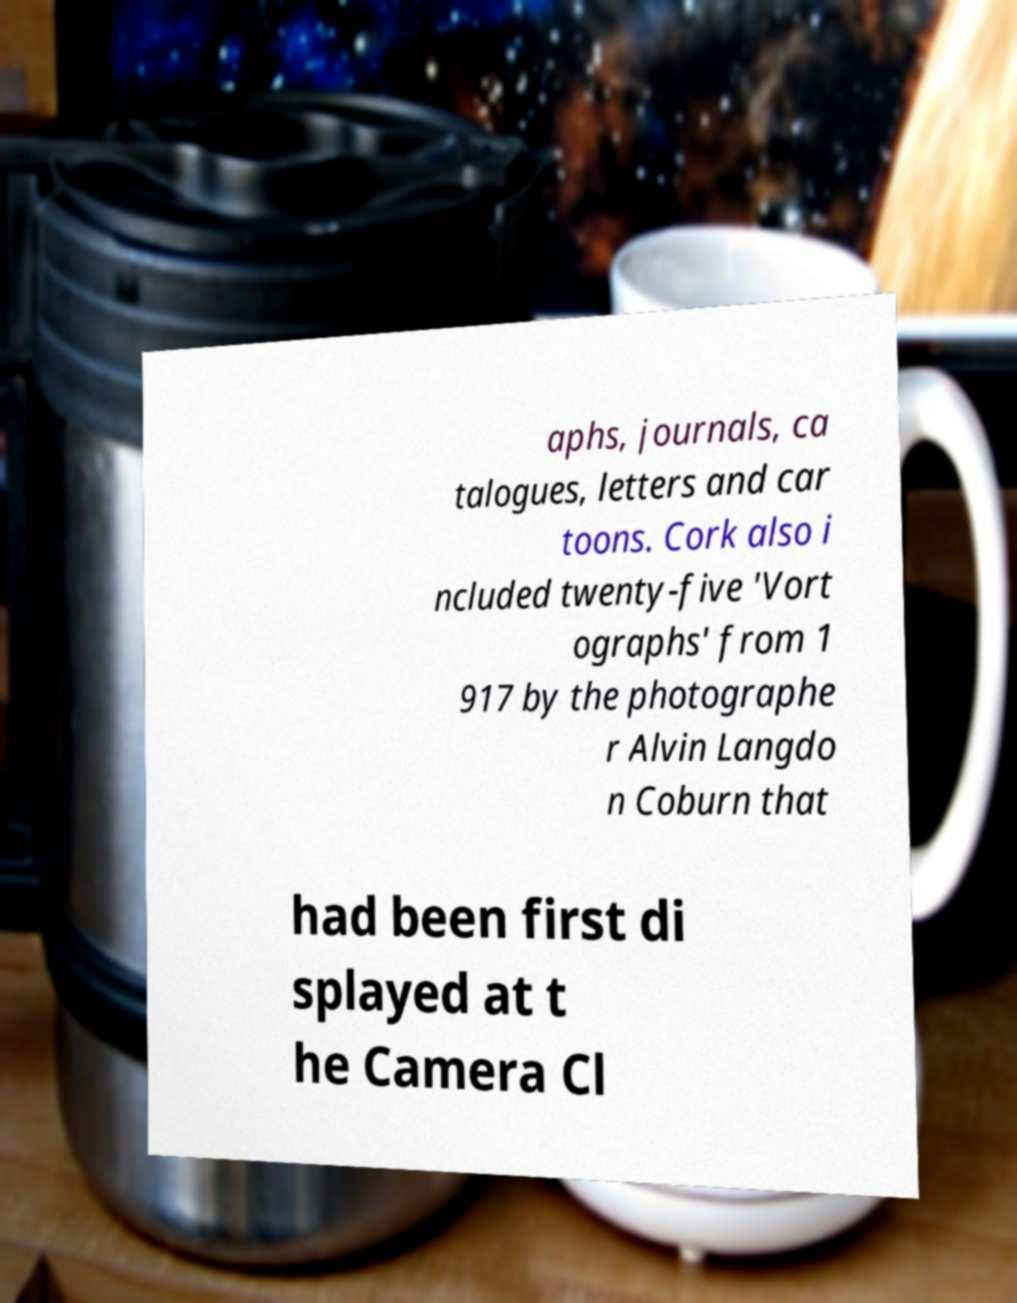Please identify and transcribe the text found in this image. aphs, journals, ca talogues, letters and car toons. Cork also i ncluded twenty-five 'Vort ographs' from 1 917 by the photographe r Alvin Langdo n Coburn that had been first di splayed at t he Camera Cl 